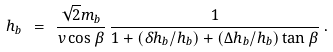<formula> <loc_0><loc_0><loc_500><loc_500>h _ { b } \ = \ \frac { \sqrt { 2 } m _ { b } } { v \cos \beta } \, \frac { 1 } { 1 + ( \delta h _ { b } / h _ { b } ) + ( \Delta h _ { b } / h _ { b } ) \tan \beta } \, .</formula> 